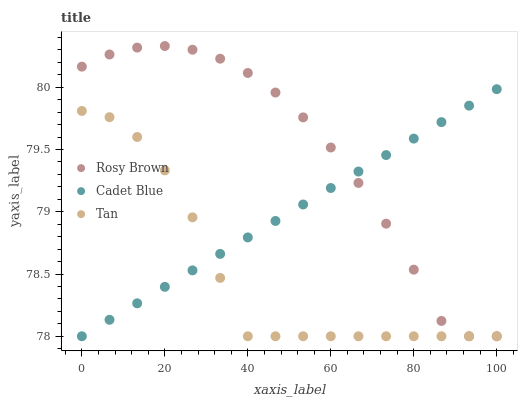Does Tan have the minimum area under the curve?
Answer yes or no. Yes. Does Rosy Brown have the maximum area under the curve?
Answer yes or no. Yes. Does Rosy Brown have the minimum area under the curve?
Answer yes or no. No. Does Tan have the maximum area under the curve?
Answer yes or no. No. Is Cadet Blue the smoothest?
Answer yes or no. Yes. Is Tan the roughest?
Answer yes or no. Yes. Is Rosy Brown the smoothest?
Answer yes or no. No. Is Rosy Brown the roughest?
Answer yes or no. No. Does Cadet Blue have the lowest value?
Answer yes or no. Yes. Does Rosy Brown have the highest value?
Answer yes or no. Yes. Does Tan have the highest value?
Answer yes or no. No. Does Rosy Brown intersect Tan?
Answer yes or no. Yes. Is Rosy Brown less than Tan?
Answer yes or no. No. Is Rosy Brown greater than Tan?
Answer yes or no. No. 